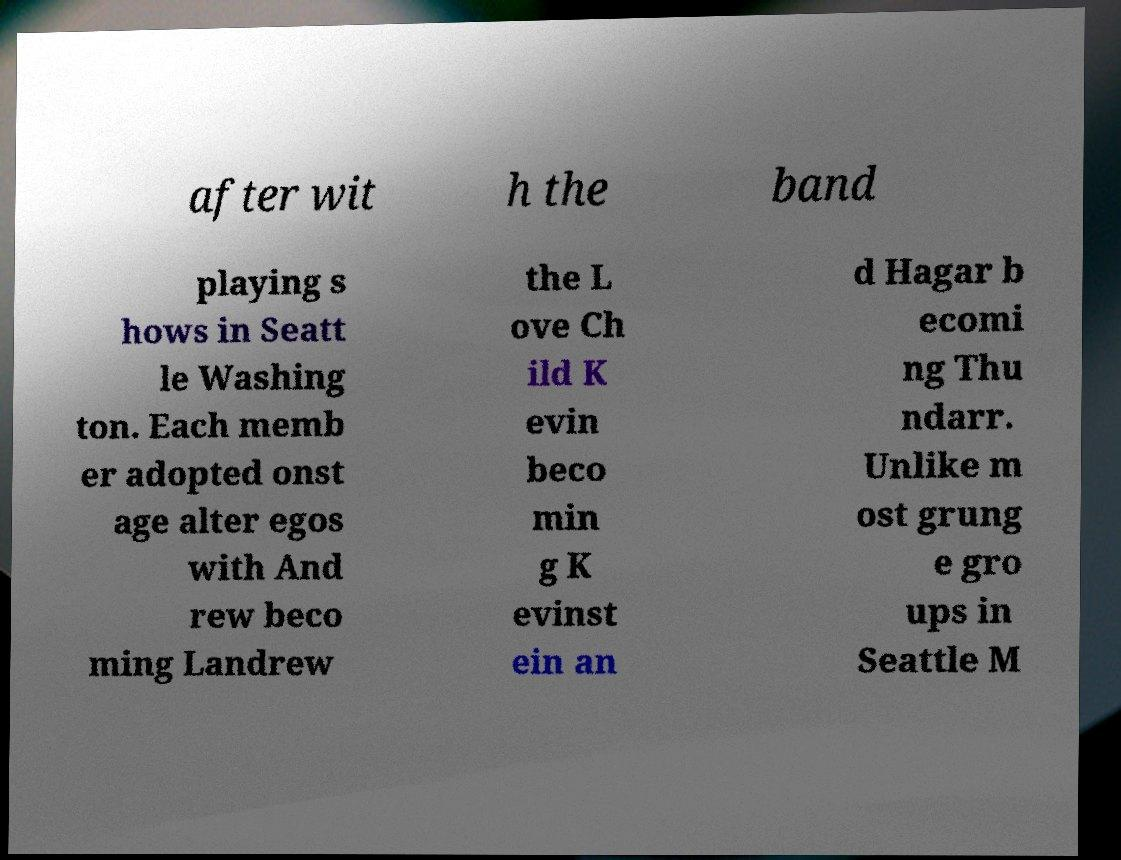Please read and relay the text visible in this image. What does it say? after wit h the band playing s hows in Seatt le Washing ton. Each memb er adopted onst age alter egos with And rew beco ming Landrew the L ove Ch ild K evin beco min g K evinst ein an d Hagar b ecomi ng Thu ndarr. Unlike m ost grung e gro ups in Seattle M 